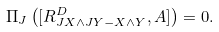<formula> <loc_0><loc_0><loc_500><loc_500>\Pi _ { J } \left ( [ R ^ { D } _ { J X \land J Y - X \land Y } , A ] \right ) = 0 .</formula> 